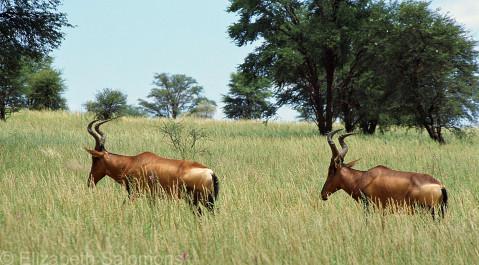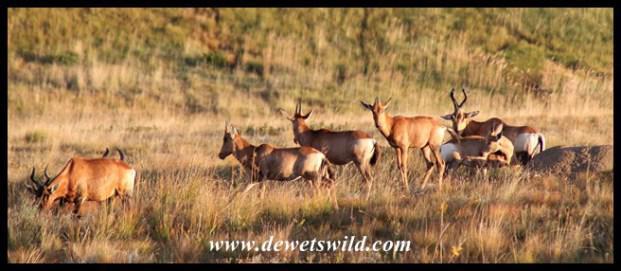The first image is the image on the left, the second image is the image on the right. For the images displayed, is the sentence "The right photo contains two kinds of animals." factually correct? Answer yes or no. No. The first image is the image on the left, the second image is the image on the right. Examine the images to the left and right. Is the description "Zebra are present in a field with horned animals in one image." accurate? Answer yes or no. No. 